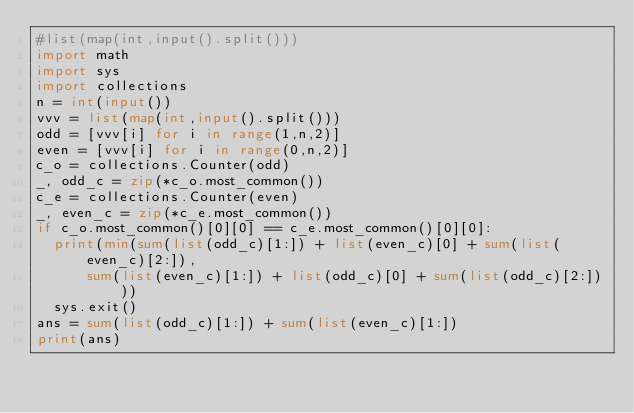<code> <loc_0><loc_0><loc_500><loc_500><_Python_>#list(map(int,input().split()))
import math
import sys
import collections
n = int(input())
vvv = list(map(int,input().split()))
odd = [vvv[i] for i in range(1,n,2)]
even = [vvv[i] for i in range(0,n,2)]
c_o = collections.Counter(odd)
_, odd_c = zip(*c_o.most_common())
c_e = collections.Counter(even)
_, even_c = zip(*c_e.most_common())
if c_o.most_common()[0][0] == c_e.most_common()[0][0]:
  print(min(sum(list(odd_c)[1:]) + list(even_c)[0] + sum(list(even_c)[2:]),
      sum(list(even_c)[1:]) + list(odd_c)[0] + sum(list(odd_c)[2:])))
  sys.exit()
ans = sum(list(odd_c)[1:]) + sum(list(even_c)[1:])
print(ans)</code> 